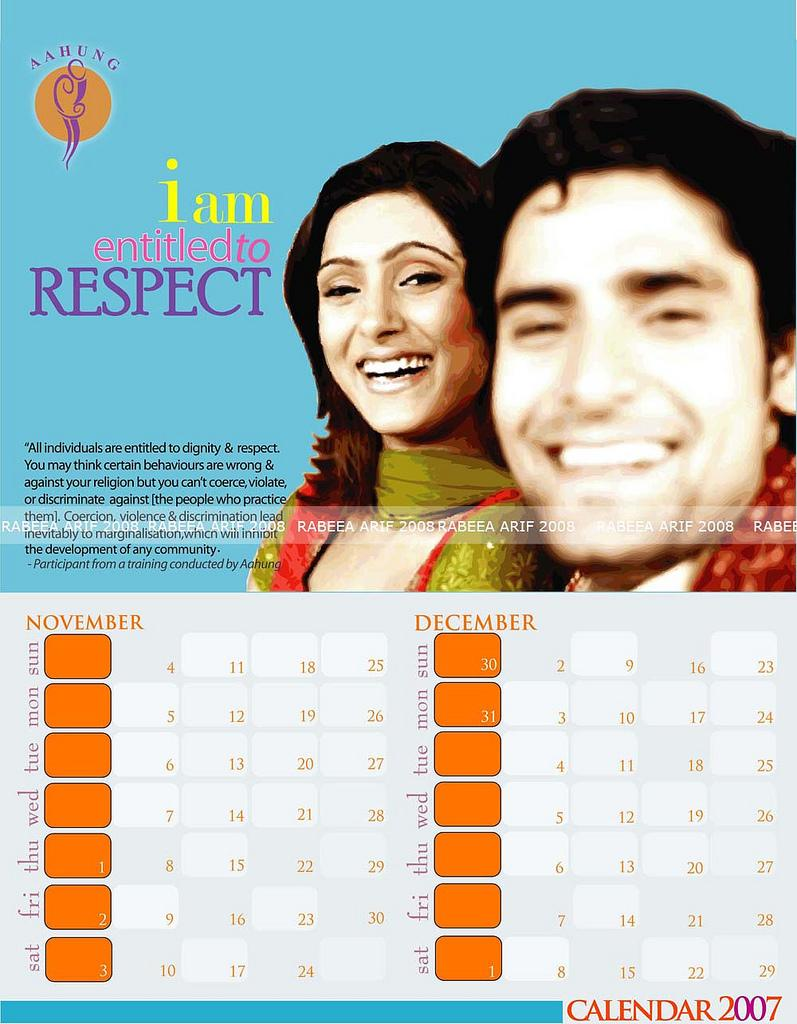What type of object is visible in the image that is related to dates or time? There is a page of a calendar in the image that appears to be from a calendar. What can be seen on the calendar page? There are images of two persons on the calendar page. What else is present on the calendar page besides the images? There are words and numbers on the calendar page. What type of icicle can be seen hanging from the calendar page in the image? There is no icicle present on the calendar page in the image. What type of minister is depicted on the calendar page? There is no minister depicted on the calendar page; it features images of two persons. 